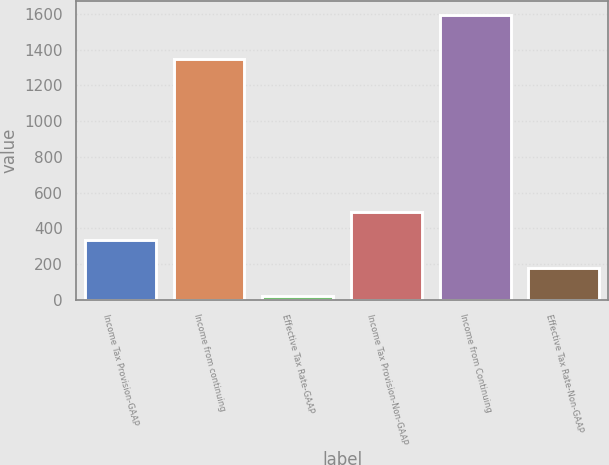Convert chart. <chart><loc_0><loc_0><loc_500><loc_500><bar_chart><fcel>Income Tax Provision-GAAP<fcel>Income from continuing<fcel>Effective Tax Rate-GAAP<fcel>Income Tax Provision-Non-GAAP<fcel>Income from Continuing<fcel>Effective Tax Rate-Non-GAAP<nl><fcel>336.66<fcel>1350.4<fcel>22.8<fcel>493.59<fcel>1592.1<fcel>179.73<nl></chart> 